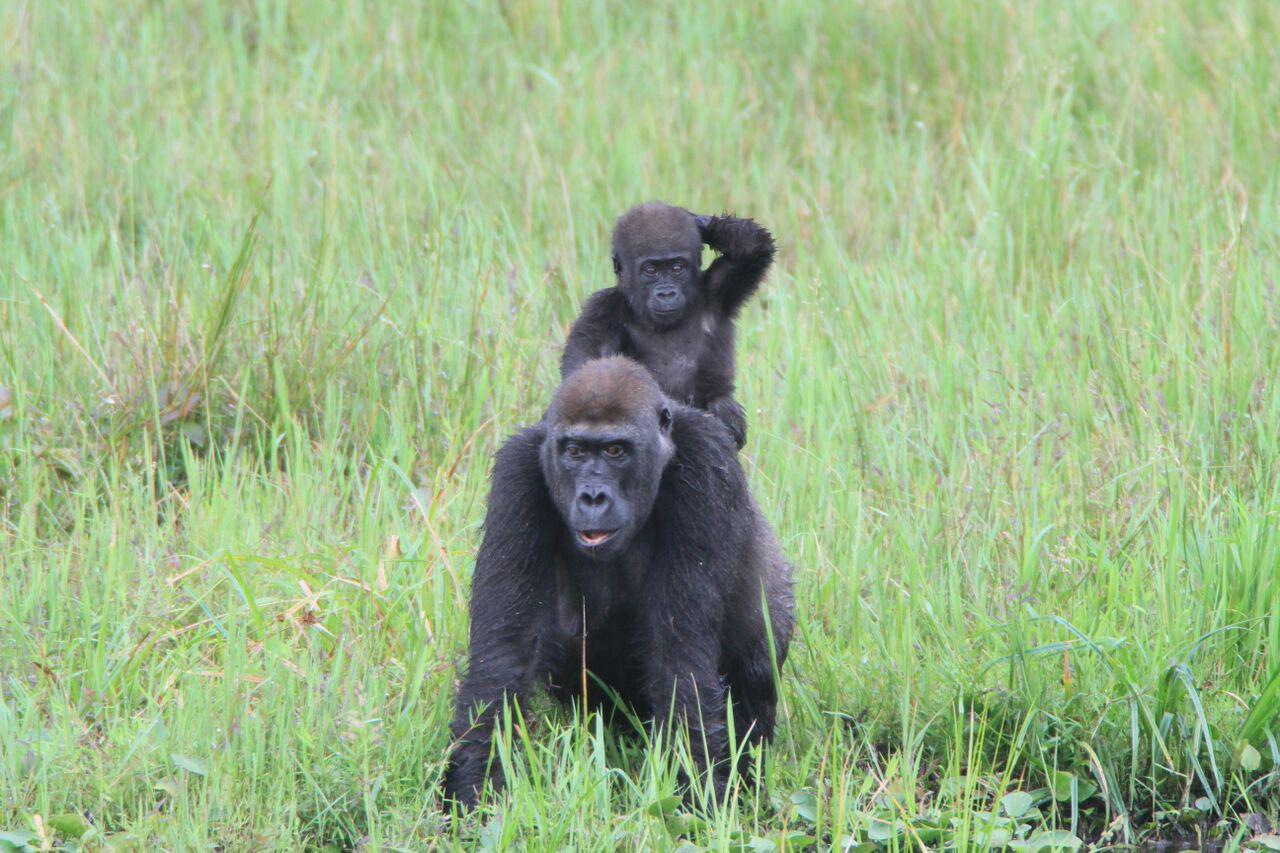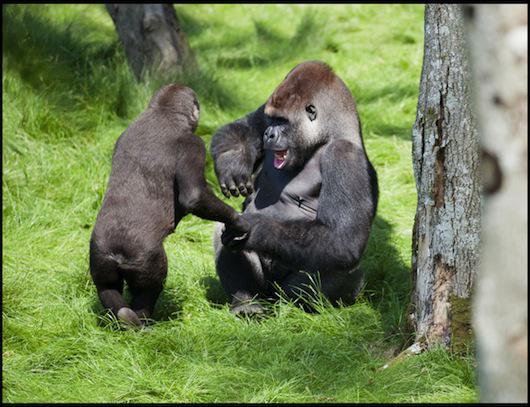The first image is the image on the left, the second image is the image on the right. For the images shown, is this caption "On one image, there is a baby gorilla on top of a bigger gorilla." true? Answer yes or no. Yes. 